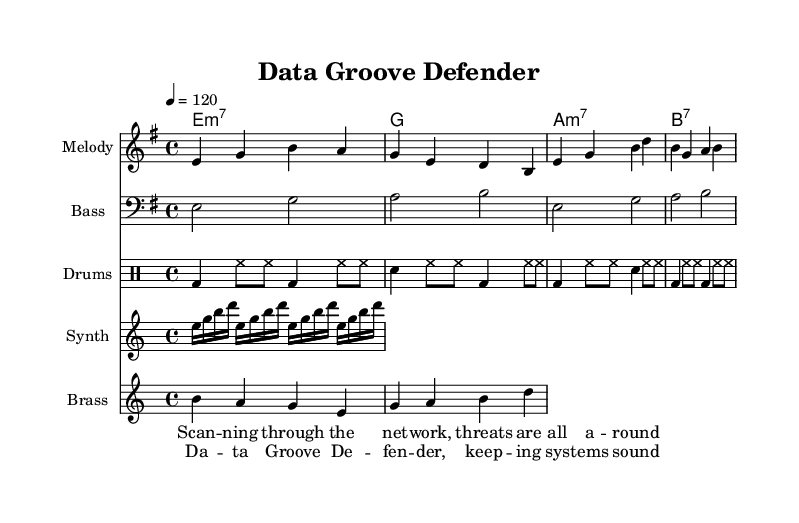What is the key signature of this music? The key signature is indicated at the beginning of the score, which shows that it is E minor, as it has one sharp (F#).
Answer: E minor What is the time signature of this piece? The time signature is shown at the beginning, and it is 4/4, which means there are four beats per measure.
Answer: 4/4 What is the tempo marking for this piece? The tempo marking is located next to the time signature and indicates the speed of the piece, which is set to 120 beats per minute.
Answer: 120 How many measures are present in the melody? By counting the measures represented in the melody staff, there are a total of 8 measures.
Answer: 8 What is the function of the bass line in this piece? The bass line supports the harmony and rhythm, providing a foundation for the chords played over the melody. It indicates the root notes that align with the chords.
Answer: Foundation What type of percussion is predominantly used in this piece? The percussion section indicates the use of a bass drum and snare drum along with hi-hats, making it clear that it uses common funk drumming elements.
Answer: Bass drum and snare How does the melodic structure reflect typical funk rhythms? The melody consists of syncopated rhythms and short phrases, which are characteristic of funk music that emphasizes groove and danceability.
Answer: Syncopated rhythms 